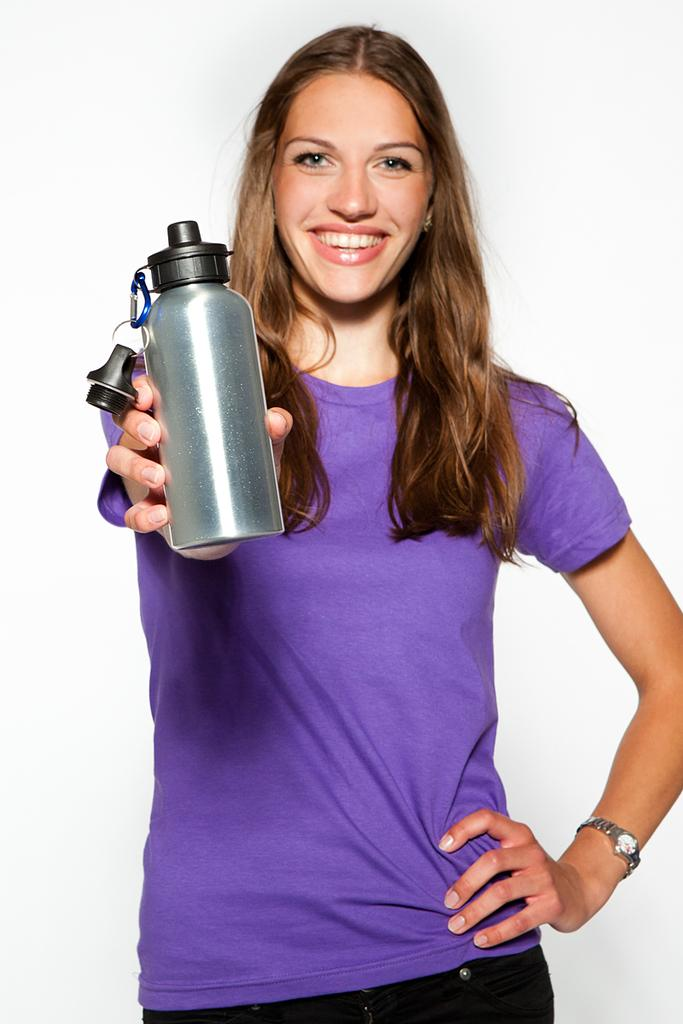Who is the main subject in the image? There is a woman in the image. What is the woman's facial expression? The woman is smiling. What is the woman holding in her hand? The woman is holding a bottle in her hand. What color is the background of the image? The background of the image is white. What direction is the woman sorting the canvas in the image? There is no canvas present in the image, and the woman is not sorting anything. 